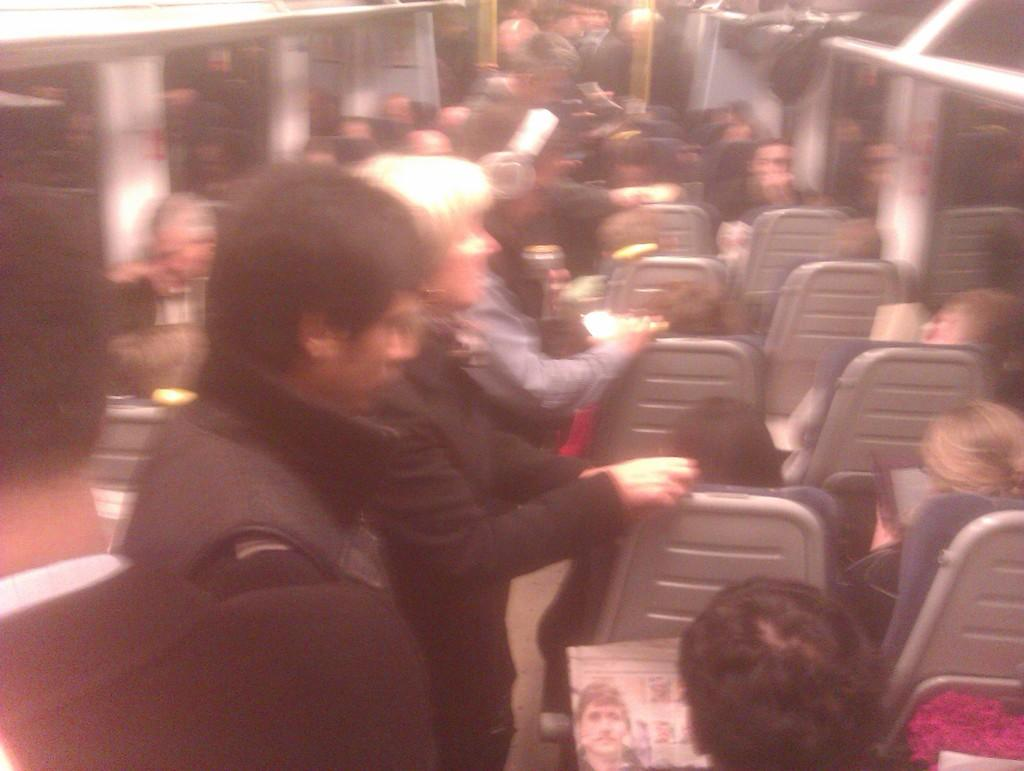What are the people in the image doing? There are people standing and sitting in the image. How are the people dressed in the image? The people are wearing different colored dresses. What can be inferred about the setting of the image? The image shows the interior of a vehicle. Can you see any fairies flying around in the image? No, there are no fairies present in the image. What type of range is visible in the image? There is no range visible in the image; it shows people inside a vehicle. 